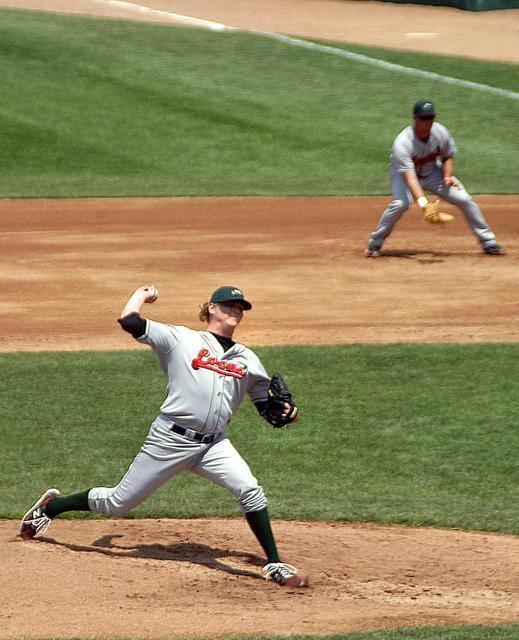How many field positions are visible in this picture?
Give a very brief answer. 2. How many people are visible?
Give a very brief answer. 2. 